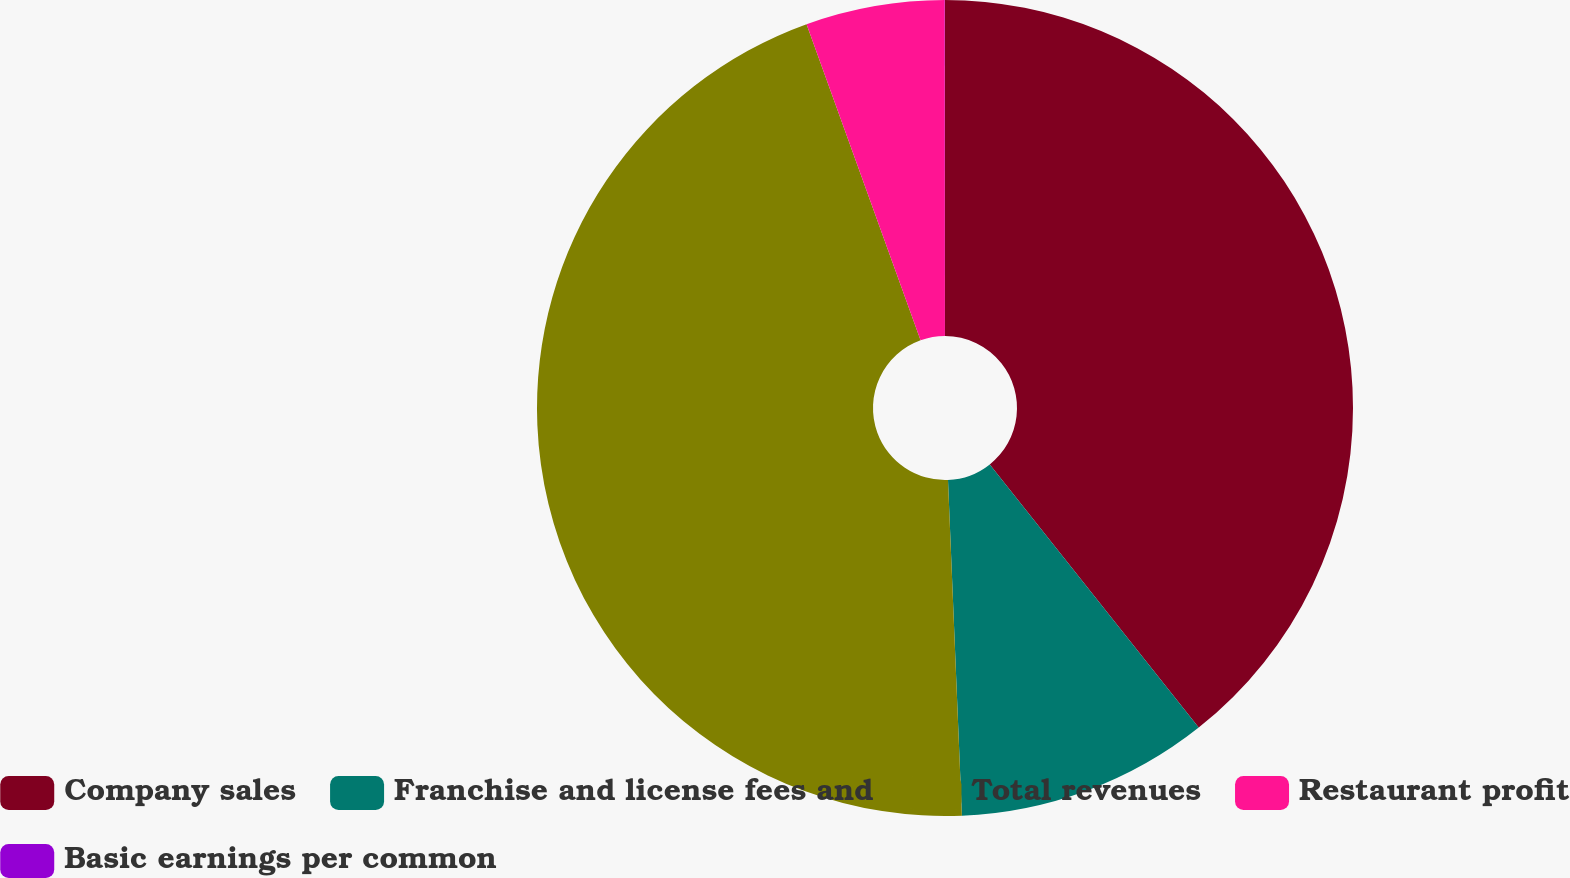Convert chart to OTSL. <chart><loc_0><loc_0><loc_500><loc_500><pie_chart><fcel>Company sales<fcel>Franchise and license fees and<fcel>Total revenues<fcel>Restaurant profit<fcel>Basic earnings per common<nl><fcel>39.32%<fcel>10.02%<fcel>45.15%<fcel>5.5%<fcel>0.01%<nl></chart> 